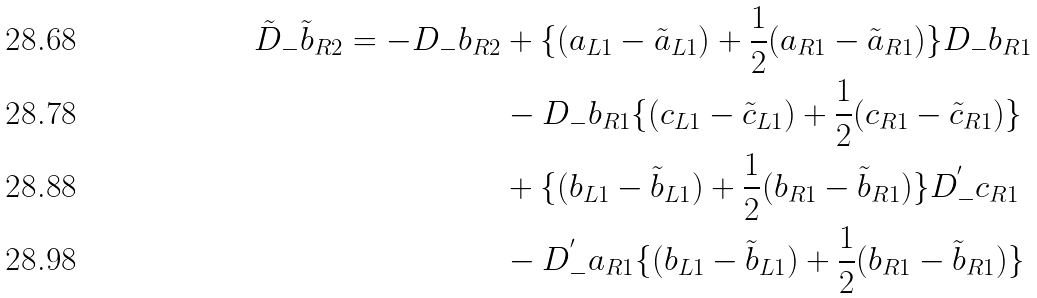<formula> <loc_0><loc_0><loc_500><loc_500>\tilde { D } _ { - } \tilde { b } _ { R 2 } = - D _ { - } b _ { R 2 } & + \{ ( a _ { L 1 } - \tilde { a } _ { L 1 } ) + \frac { 1 } { 2 } ( a _ { R 1 } - \tilde { a } _ { R 1 } ) \} D _ { - } b _ { R 1 } \\ & - D _ { - } b _ { R 1 } \{ ( c _ { L 1 } - \tilde { c } _ { L 1 } ) + \frac { 1 } { 2 } ( c _ { R 1 } - \tilde { c } _ { R 1 } ) \} \\ & + \{ ( b _ { L 1 } - \tilde { b } _ { L 1 } ) + \frac { 1 } { 2 } ( b _ { R 1 } - \tilde { b } _ { R 1 } ) \} D _ { - } ^ { ^ { \prime } } c _ { R 1 } \\ & - D _ { - } ^ { ^ { \prime } } a _ { R 1 } \{ ( b _ { L 1 } - \tilde { b } _ { L 1 } ) + \frac { 1 } { 2 } ( b _ { R 1 } - \tilde { b } _ { R 1 } ) \}</formula> 